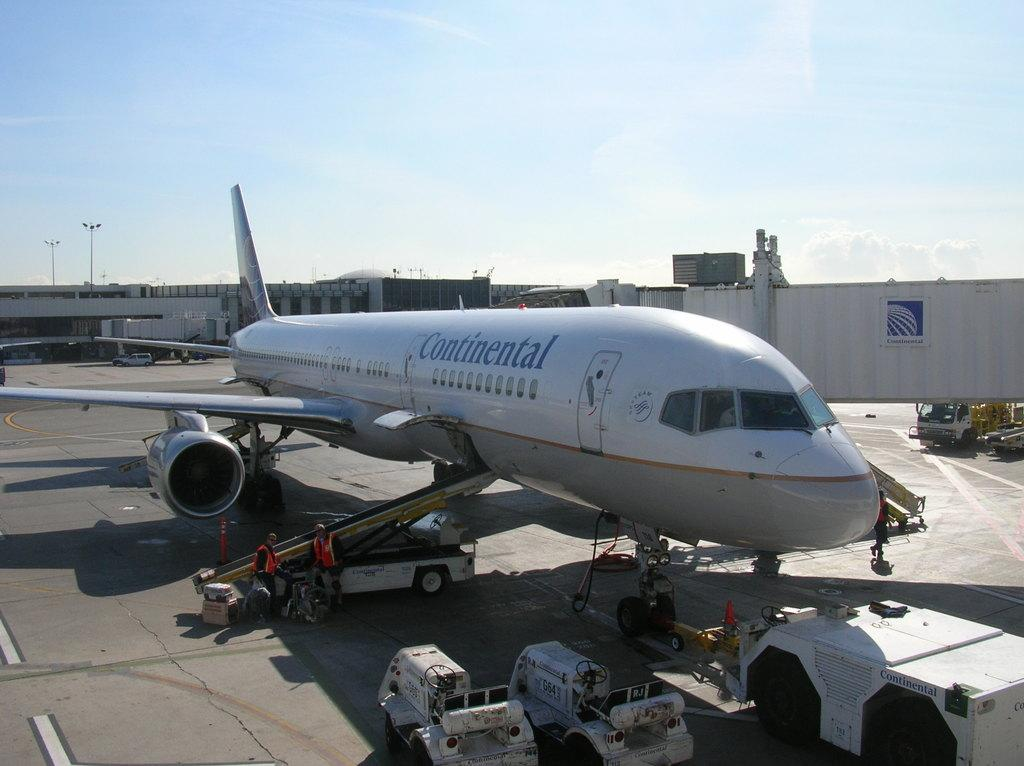Provide a one-sentence caption for the provided image. Continental airplane with the logo sky team in blue. 